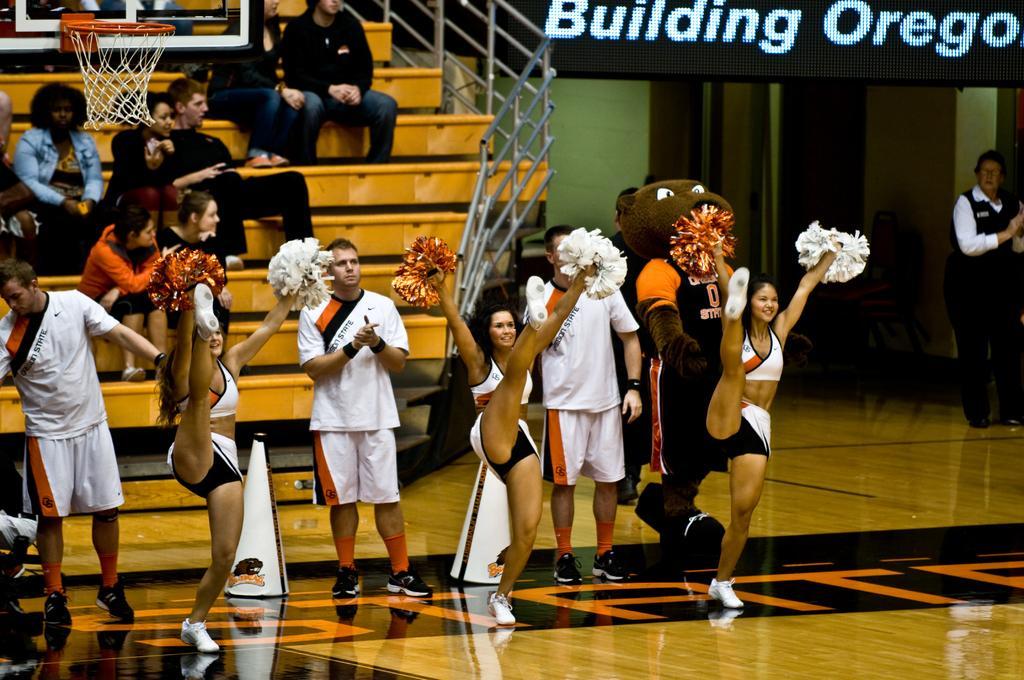In one or two sentences, can you explain what this image depicts? In this image there are a few cheer girls dancing on the court, behind them there are a few men standing and clapping, behind them there are a few people seated on stairs, to the right of the image there is a security guard standing, at the top left of the image there is a basket. 